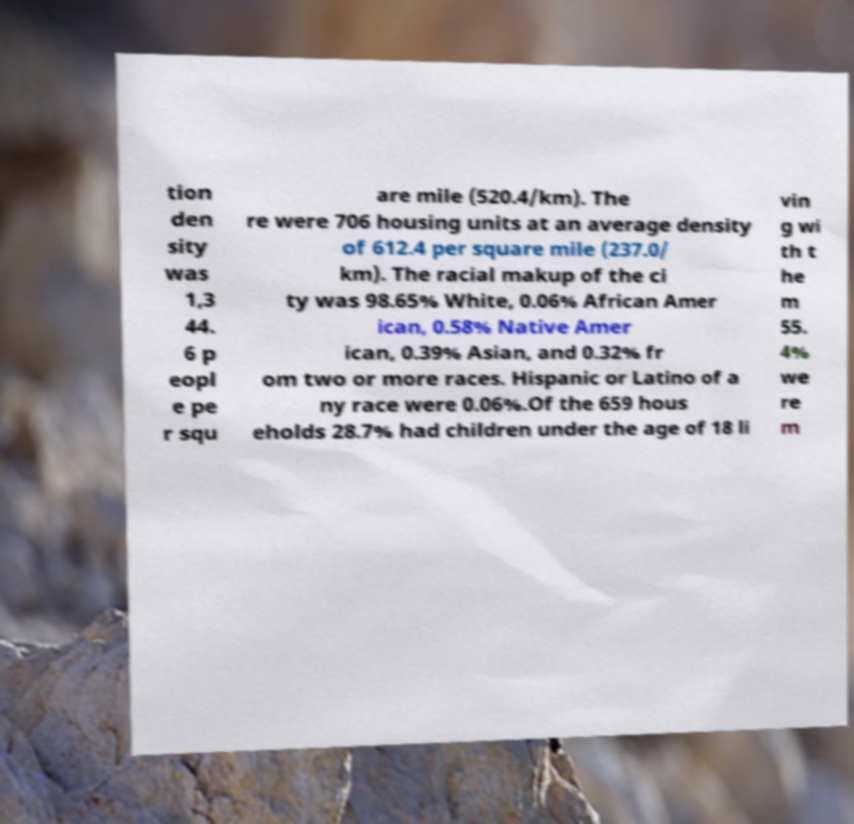Please read and relay the text visible in this image. What does it say? tion den sity was 1,3 44. 6 p eopl e pe r squ are mile (520.4/km). The re were 706 housing units at an average density of 612.4 per square mile (237.0/ km). The racial makup of the ci ty was 98.65% White, 0.06% African Amer ican, 0.58% Native Amer ican, 0.39% Asian, and 0.32% fr om two or more races. Hispanic or Latino of a ny race were 0.06%.Of the 659 hous eholds 28.7% had children under the age of 18 li vin g wi th t he m 55. 4% we re m 